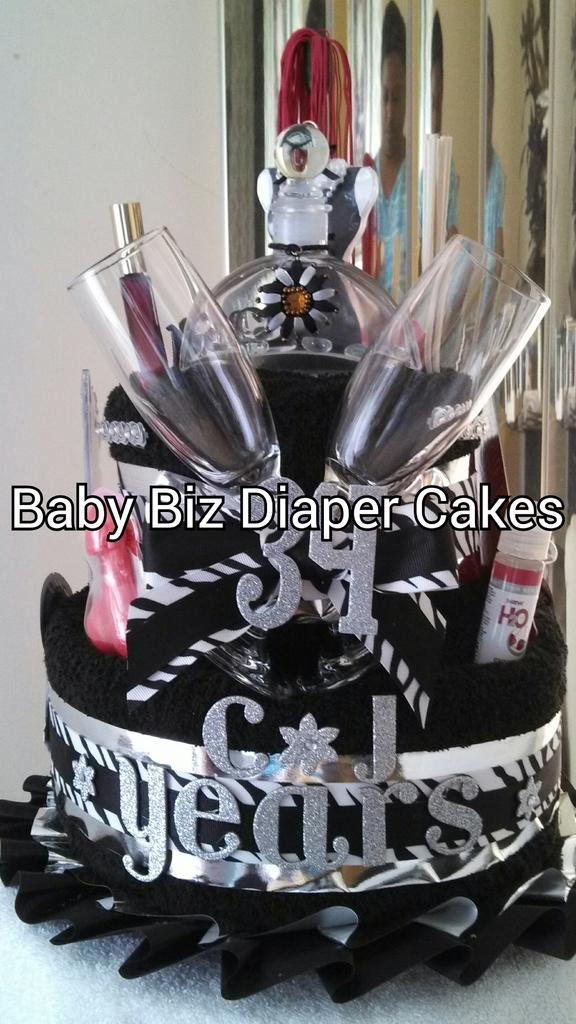What can be seen in the image? There is an object in the image. Can you describe the appearance of the object? The object is in black and silver color. What is visible in the background of the image? There is a white wall in the background of the image. How many houses are visible in the image? There are no houses visible in the image; it only features an object and a white wall in the background. 